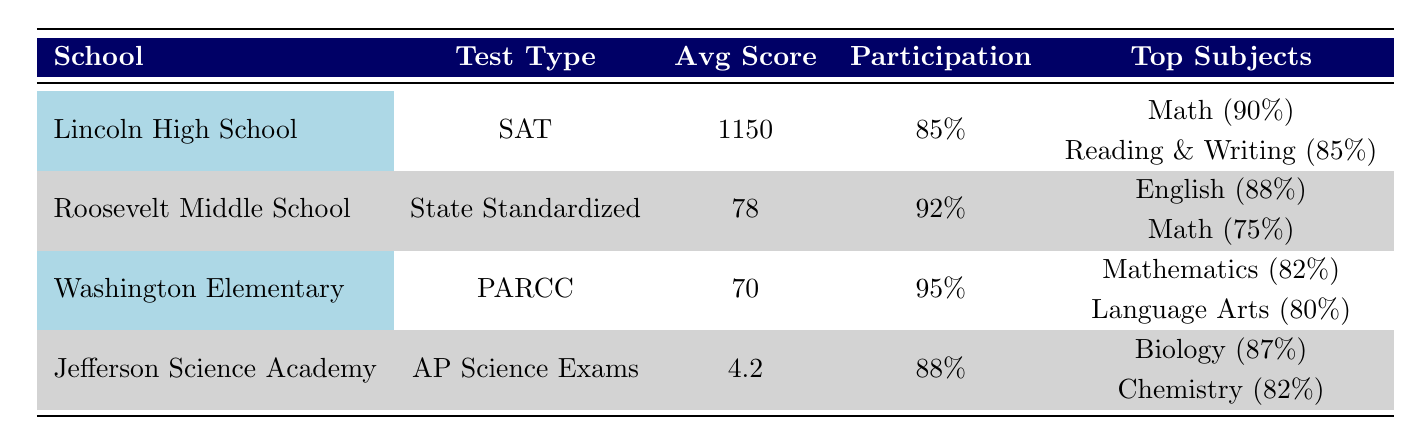What is the average score of Lincoln High School on the SAT? The Average Score for Lincoln High School on the SAT is specified in the table as 1150.
Answer: 1150 Which school had the highest participation rate? The participation rates for the schools are as follows: Lincoln High School 85%, Roosevelt Middle School 92%, Washington Elementary School 95%, and Jefferson Science Academy 88%. The highest participation rate is therefore 95% for Washington Elementary School.
Answer: 95% Is the top subject for Roosevelt Middle School in English? The top subjects for Roosevelt Middle School are stated as Math (75%) and English (88%). Since English is listed as one of the top subjects and has a higher percentage than Math, the statement is true.
Answer: Yes What was the average score in Mathematics for Washington Elementary School? The average score for Mathematics at Washington Elementary School is listed in the table as 72.
Answer: 72 What is the difference in average scores between Lincoln High School and Roosevelt Middle School? Lincoln High School's average score is 1150, and Roosevelt Middle School's average score is 78. The difference is calculated as 1150 - 78 = 1072.
Answer: 1072 What is the average of the top percentages for all subjects in Jefferson Science Academy? The top percentages for Jefferson Science Academy are Biology (87%) and Chemistry (82%). The average is calculated as (87 + 82) / 2 = 84.5.
Answer: 84.5 Does Washington Elementary School have a lower average score than Lincoln High School? Lincoln High School's average score is 1150, whereas Washington Elementary School's average score is 70. Since 70 is less than 1150, it can be concluded that this statement is true.
Answer: Yes What is the overall average score across all tested subjects for Lincoln High School? Lincoln High School's average scores for the two subjects (Math 600 and Evidence-Based Reading and Writing 550) can be calculated: (600 + 550) / 2 = 575.
Answer: 575 Which school performed the best in terms of average score and what was that score? Lincoln High School has the highest average score of 1150 among the listed schools.
Answer: Lincoln High School, 1150 